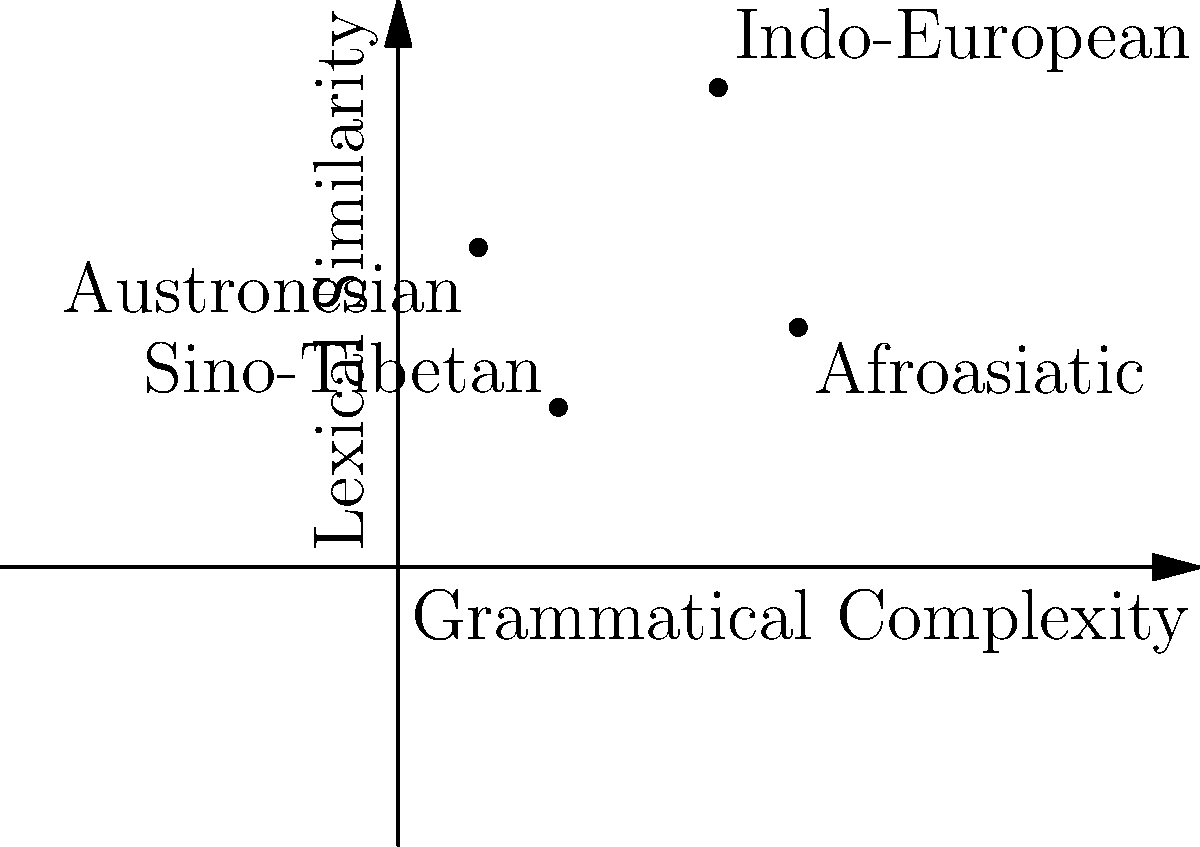In the coordinate plane above, language families are mapped based on their grammatical complexity (x-axis) and lexical similarity (y-axis). Which language family exhibits the highest grammatical complexity and lexical similarity according to this representation? To determine which language family has the highest grammatical complexity and lexical similarity, we need to analyze the position of each plotted point:

1. Indo-European: (2, 3)
2. Sino-Tibetan: (1, 1)
3. Austronesian: (0.5, 2)
4. Afroasiatic: (2.5, 1.5)

The x-coordinate represents grammatical complexity, while the y-coordinate represents lexical similarity.

To have the highest values in both categories, we need to find the point that is furthest to the right (highest x-value) and highest up (highest y-value).

Comparing x-coordinates (grammatical complexity):
Afroasiatic (2.5) > Indo-European (2) > Sino-Tibetan (1) > Austronesian (0.5)

Comparing y-coordinates (lexical similarity):
Indo-European (3) > Austronesian (2) > Afroasiatic (1.5) > Sino-Tibetan (1)

The Indo-European family has the highest y-coordinate (3) and the second-highest x-coordinate (2), making it the language family with the highest overall combination of grammatical complexity and lexical similarity.
Answer: Indo-European 